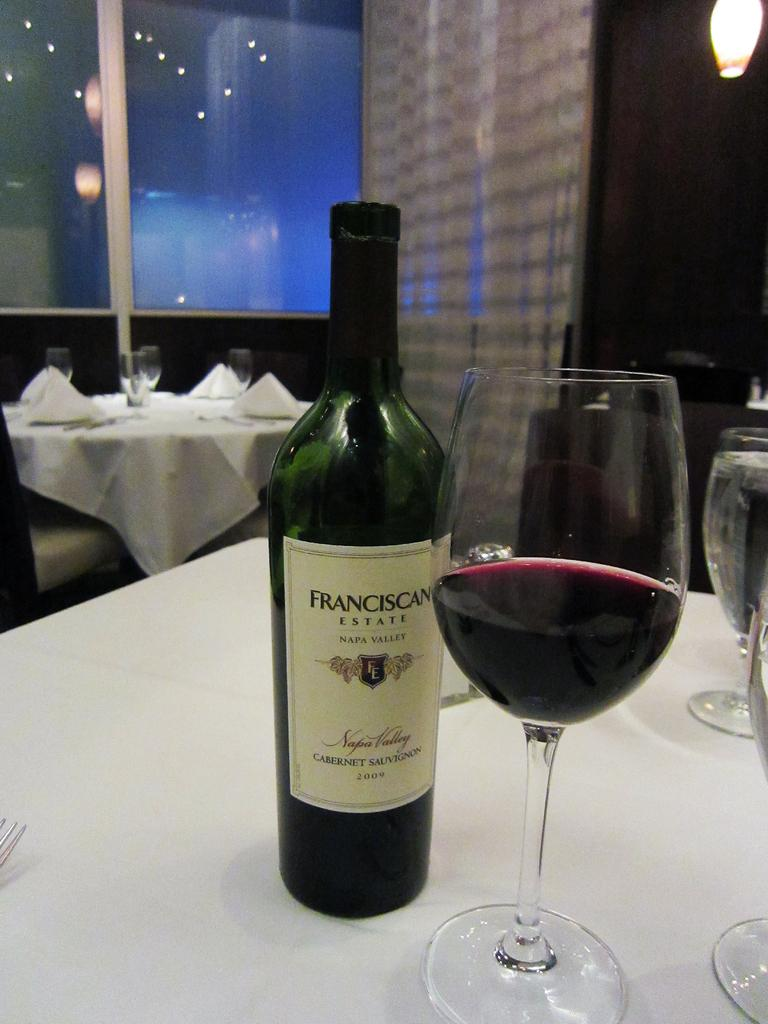<image>
Provide a brief description of the given image. A bottle of Franciscan Estate wine is next to a glass of wine on a white table cloth. 